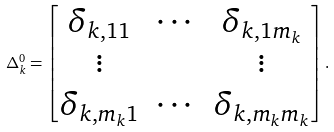<formula> <loc_0><loc_0><loc_500><loc_500>\Delta ^ { 0 } _ { k } = \begin{bmatrix} \delta _ { k , 1 1 } & \cdots & \delta _ { k , 1 m _ { k } } \\ \vdots & & \vdots \\ \delta _ { k , m _ { k } 1 } & \cdots & \delta _ { k , m _ { k } m _ { k } } \end{bmatrix} .</formula> 